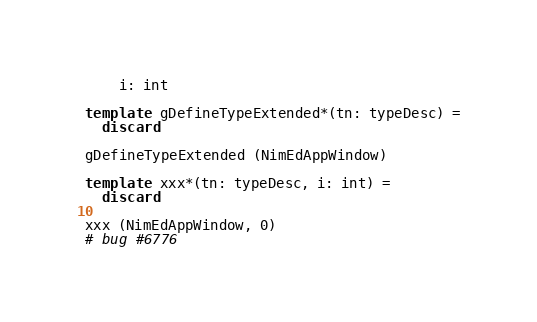<code> <loc_0><loc_0><loc_500><loc_500><_Nim_>    i: int

template gDefineTypeExtended*(tn: typeDesc) =
  discard

gDefineTypeExtended (NimEdAppWindow)

template xxx*(tn: typeDesc, i: int) =
  discard

xxx (NimEdAppWindow, 0)
# bug #6776
</code> 